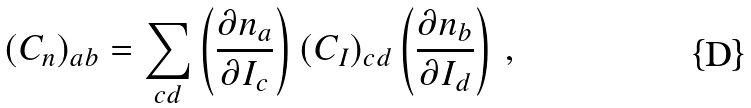<formula> <loc_0><loc_0><loc_500><loc_500>( C _ { n } ) _ { a b } = \sum _ { c d } \left ( \frac { \partial n _ { a } } { \partial I _ { c } } \right ) ( C _ { I } ) _ { c d } \left ( \frac { \partial n _ { b } } { \partial I _ { d } } \right ) \, ,</formula> 